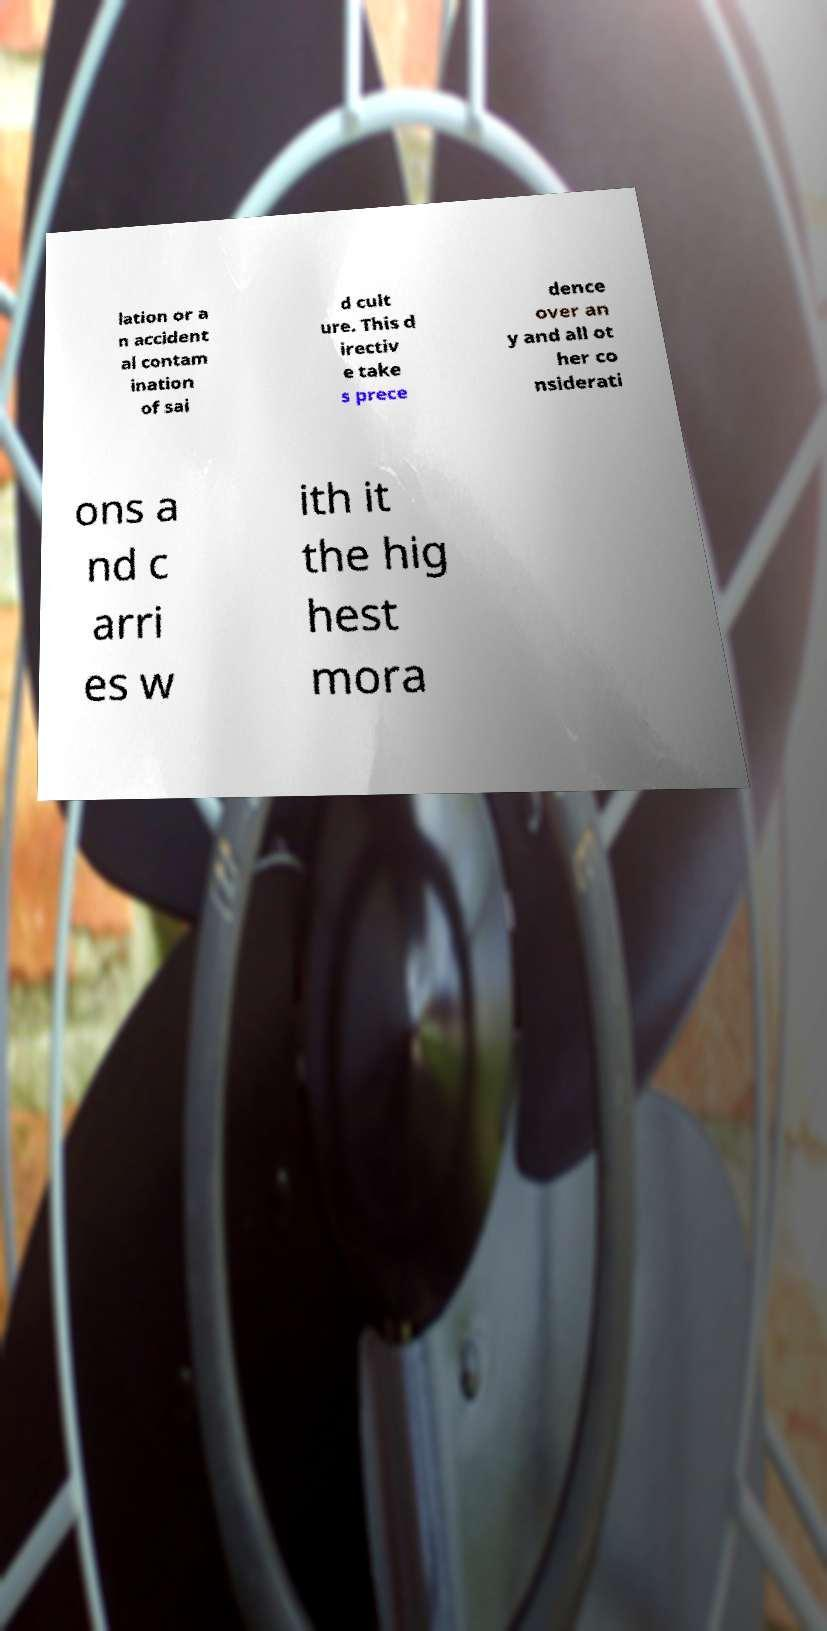Please identify and transcribe the text found in this image. lation or a n accident al contam ination of sai d cult ure. This d irectiv e take s prece dence over an y and all ot her co nsiderati ons a nd c arri es w ith it the hig hest mora 